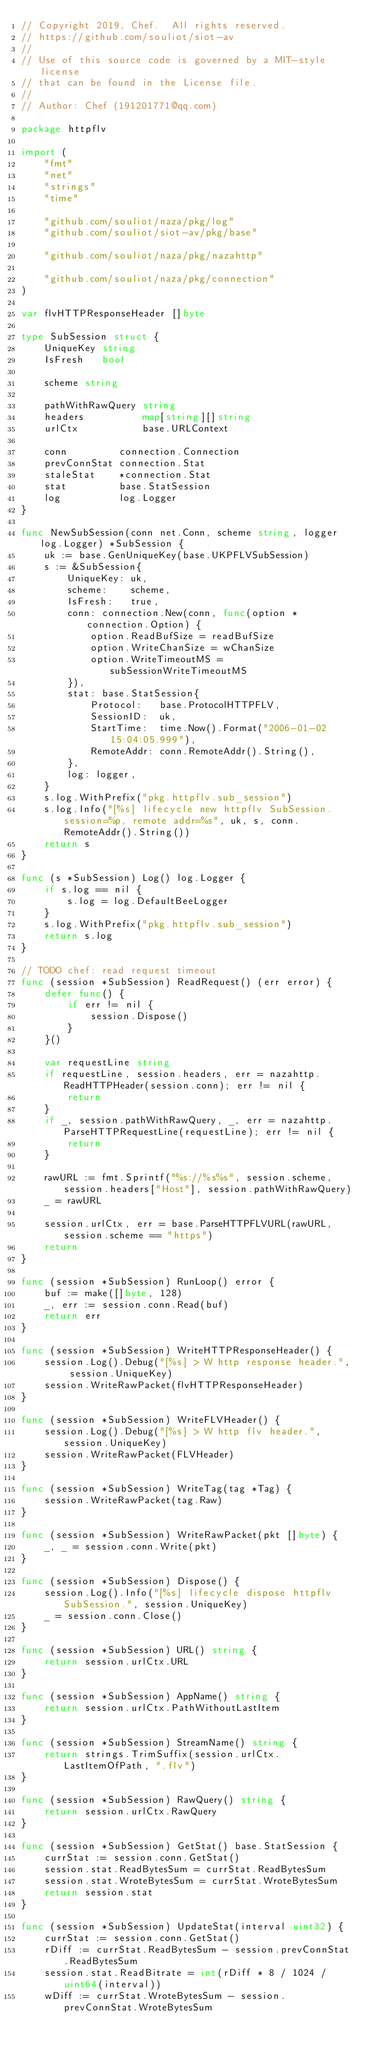<code> <loc_0><loc_0><loc_500><loc_500><_Go_>// Copyright 2019, Chef.  All rights reserved.
// https://github.com/souliot/siot-av
//
// Use of this source code is governed by a MIT-style license
// that can be found in the License file.
//
// Author: Chef (191201771@qq.com)

package httpflv

import (
	"fmt"
	"net"
	"strings"
	"time"

	"github.com/souliot/naza/pkg/log"
	"github.com/souliot/siot-av/pkg/base"

	"github.com/souliot/naza/pkg/nazahttp"

	"github.com/souliot/naza/pkg/connection"
)

var flvHTTPResponseHeader []byte

type SubSession struct {
	UniqueKey string
	IsFresh   bool

	scheme string

	pathWithRawQuery string
	headers          map[string][]string
	urlCtx           base.URLContext

	conn         connection.Connection
	prevConnStat connection.Stat
	staleStat    *connection.Stat
	stat         base.StatSession
	log          log.Logger
}

func NewSubSession(conn net.Conn, scheme string, logger log.Logger) *SubSession {
	uk := base.GenUniqueKey(base.UKPFLVSubSession)
	s := &SubSession{
		UniqueKey: uk,
		scheme:    scheme,
		IsFresh:   true,
		conn: connection.New(conn, func(option *connection.Option) {
			option.ReadBufSize = readBufSize
			option.WriteChanSize = wChanSize
			option.WriteTimeoutMS = subSessionWriteTimeoutMS
		}),
		stat: base.StatSession{
			Protocol:   base.ProtocolHTTPFLV,
			SessionID:  uk,
			StartTime:  time.Now().Format("2006-01-02 15:04:05.999"),
			RemoteAddr: conn.RemoteAddr().String(),
		},
		log: logger,
	}
	s.log.WithPrefix("pkg.httpflv.sub_session")
	s.log.Info("[%s] lifecycle new httpflv SubSession. session=%p, remote addr=%s", uk, s, conn.RemoteAddr().String())
	return s
}

func (s *SubSession) Log() log.Logger {
	if s.log == nil {
		s.log = log.DefaultBeeLogger
	}
	s.log.WithPrefix("pkg.httpflv.sub_session")
	return s.log
}

// TODO chef: read request timeout
func (session *SubSession) ReadRequest() (err error) {
	defer func() {
		if err != nil {
			session.Dispose()
		}
	}()

	var requestLine string
	if requestLine, session.headers, err = nazahttp.ReadHTTPHeader(session.conn); err != nil {
		return
	}
	if _, session.pathWithRawQuery, _, err = nazahttp.ParseHTTPRequestLine(requestLine); err != nil {
		return
	}

	rawURL := fmt.Sprintf("%s://%s%s", session.scheme, session.headers["Host"], session.pathWithRawQuery)
	_ = rawURL

	session.urlCtx, err = base.ParseHTTPFLVURL(rawURL, session.scheme == "https")
	return
}

func (session *SubSession) RunLoop() error {
	buf := make([]byte, 128)
	_, err := session.conn.Read(buf)
	return err
}

func (session *SubSession) WriteHTTPResponseHeader() {
	session.Log().Debug("[%s] > W http response header.", session.UniqueKey)
	session.WriteRawPacket(flvHTTPResponseHeader)
}

func (session *SubSession) WriteFLVHeader() {
	session.Log().Debug("[%s] > W http flv header.", session.UniqueKey)
	session.WriteRawPacket(FLVHeader)
}

func (session *SubSession) WriteTag(tag *Tag) {
	session.WriteRawPacket(tag.Raw)
}

func (session *SubSession) WriteRawPacket(pkt []byte) {
	_, _ = session.conn.Write(pkt)
}

func (session *SubSession) Dispose() {
	session.Log().Info("[%s] lifecycle dispose httpflv SubSession.", session.UniqueKey)
	_ = session.conn.Close()
}

func (session *SubSession) URL() string {
	return session.urlCtx.URL
}

func (session *SubSession) AppName() string {
	return session.urlCtx.PathWithoutLastItem
}

func (session *SubSession) StreamName() string {
	return strings.TrimSuffix(session.urlCtx.LastItemOfPath, ".flv")
}

func (session *SubSession) RawQuery() string {
	return session.urlCtx.RawQuery
}

func (session *SubSession) GetStat() base.StatSession {
	currStat := session.conn.GetStat()
	session.stat.ReadBytesSum = currStat.ReadBytesSum
	session.stat.WroteBytesSum = currStat.WroteBytesSum
	return session.stat
}

func (session *SubSession) UpdateStat(interval uint32) {
	currStat := session.conn.GetStat()
	rDiff := currStat.ReadBytesSum - session.prevConnStat.ReadBytesSum
	session.stat.ReadBitrate = int(rDiff * 8 / 1024 / uint64(interval))
	wDiff := currStat.WroteBytesSum - session.prevConnStat.WroteBytesSum</code> 